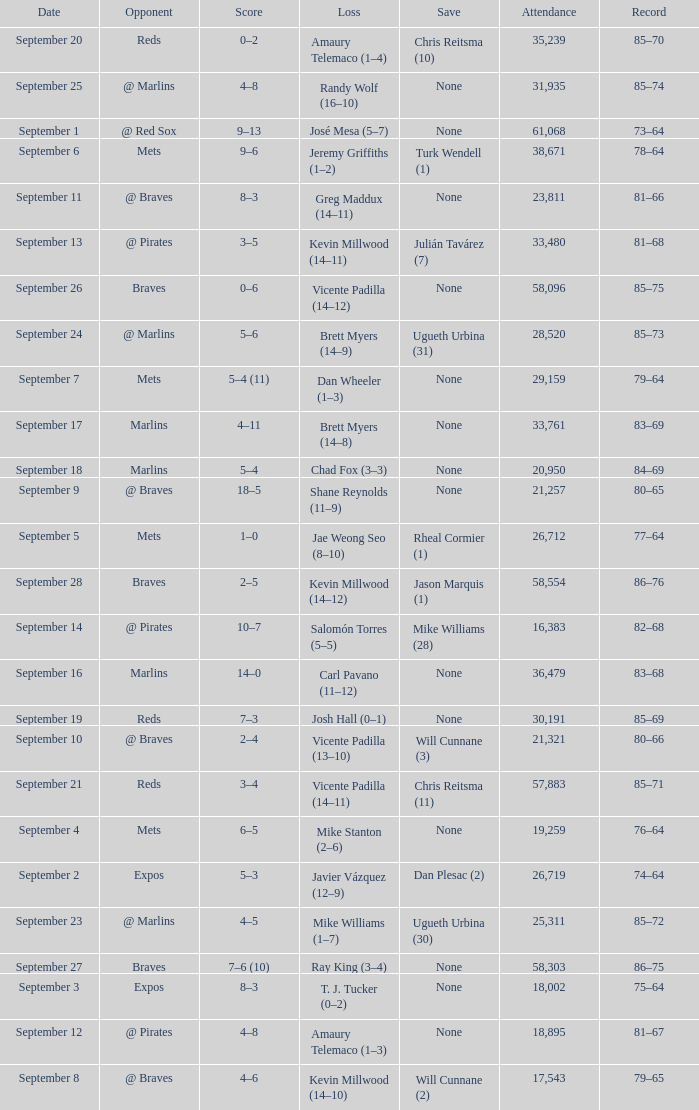What was the attendance at game with a loss of Josh Hall (0–1)? 30191.0. 